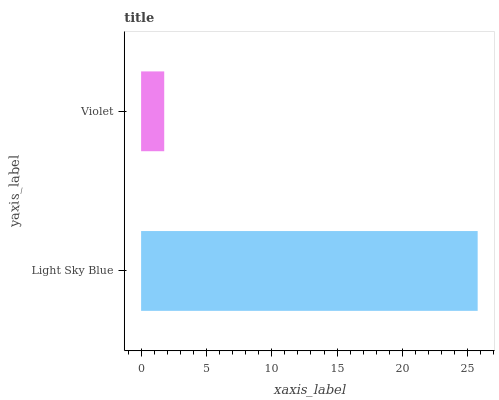Is Violet the minimum?
Answer yes or no. Yes. Is Light Sky Blue the maximum?
Answer yes or no. Yes. Is Violet the maximum?
Answer yes or no. No. Is Light Sky Blue greater than Violet?
Answer yes or no. Yes. Is Violet less than Light Sky Blue?
Answer yes or no. Yes. Is Violet greater than Light Sky Blue?
Answer yes or no. No. Is Light Sky Blue less than Violet?
Answer yes or no. No. Is Light Sky Blue the high median?
Answer yes or no. Yes. Is Violet the low median?
Answer yes or no. Yes. Is Violet the high median?
Answer yes or no. No. Is Light Sky Blue the low median?
Answer yes or no. No. 